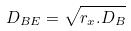Convert formula to latex. <formula><loc_0><loc_0><loc_500><loc_500>D _ { B E } = \sqrt { r _ { x } . D _ { B } }</formula> 